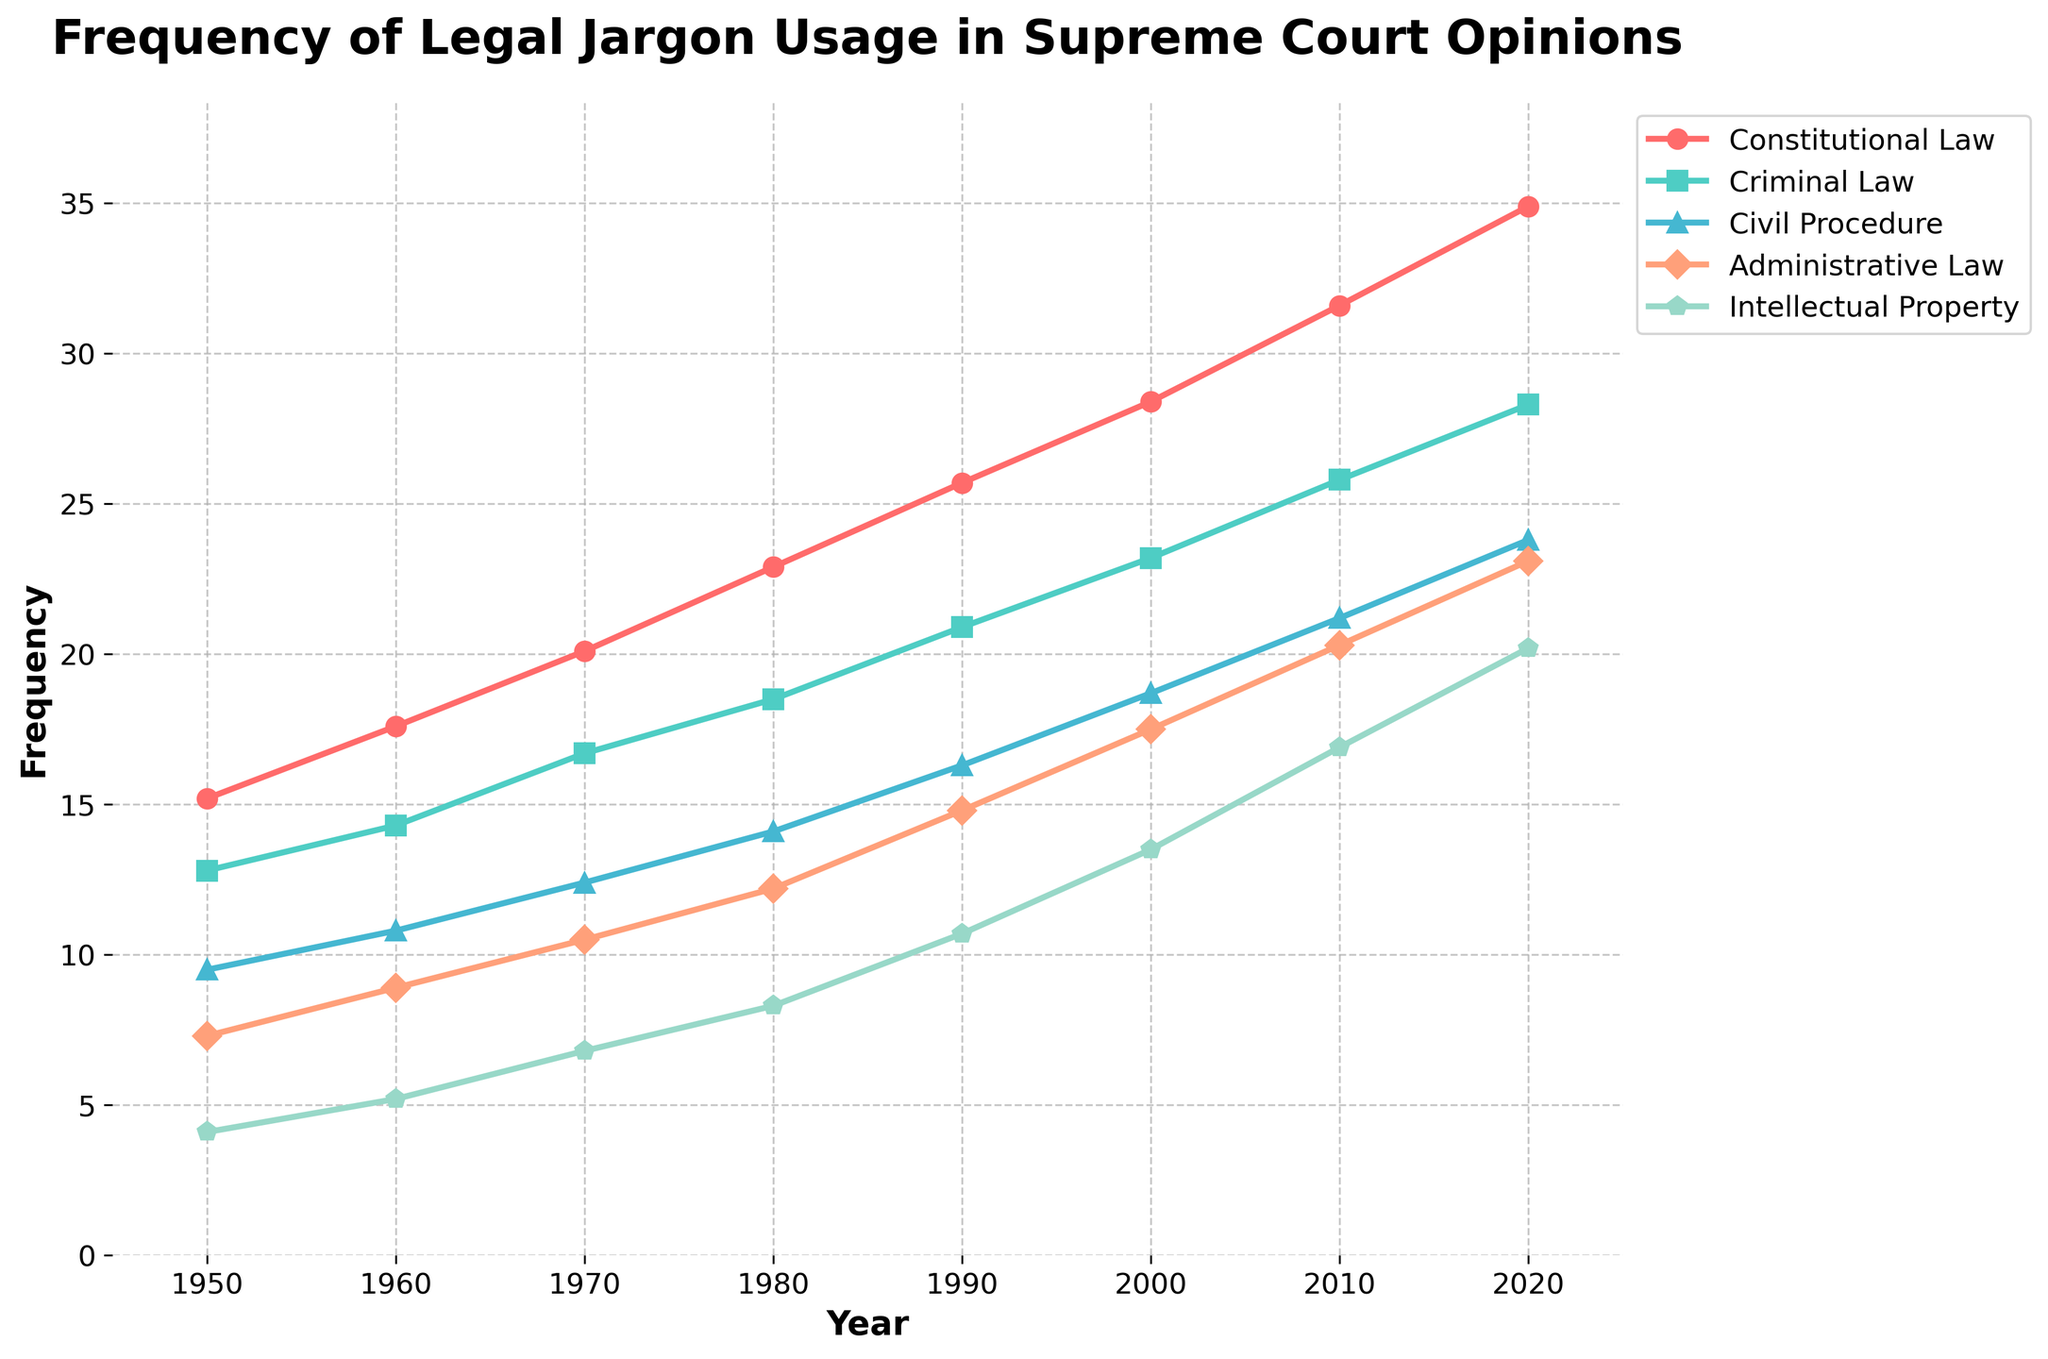what area of law had the highest frequency in 2020? Look at the 2020 value for each line and identify the highest. "Constitutional Law" is the highest at 34.9.
Answer: Constitutional Law Which two areas of law had the closest frequencies in 1970? Compare the values for each area in 1970 to find the two closest: Criminal Law (16.7) and Civil Procedure (12.4) differ by 4.3.
Answer: Criminal Law and Civil Procedure Which area of law saw the largest change in frequency from 1950 to 2020? Calculate the change for each area from 1950 to 2020. Constitutional Law changed by 34.9 - 15.2 = 19.7, which is the largest increase.
Answer: Constitutional Law What is the average frequency of Intellectual Property over the years provided? Sum the frequencies for Intellectual Property and divide by the number of years: (4.1 + 5.2 + 6.8 + 8.3 + 10.7 + 13.5 + 16.9 + 20.2) / 8 = 10.7
Answer: 10.7 Which area of law had the lowest frequency in 1980? Look at the 1980 values for each area and identify the lowest: "Intellectual Property" at 8.3.
Answer: Intellectual Property In what year did Civil Procedure surpass 20 in frequency? Identify the year where Civil Procedure first exceeds 20: It was 2010 with a value of 21.2.
Answer: 2010 How much did Administrative Law grow from 1990 to 2010? Subtract the 1990 value from the 2010 value for Administrative Law: 20.3 - 14.8 = 5.5
Answer: 5.5 What is the difference in frequency between Criminal Law and Intellectual Property in 2020? Subtract the 2020 value of Intellectual Property from Criminal Law: 28.3 - 20.2 = 8.1
Answer: 8.1 Which color represents the trend of Criminal Law in the visual? Identify the color used for the Criminal Law line in the plot, which is turquoise.
Answer: turquoise Which area saw its frequency more than triple from 1950 to 2020? Identify the areas whose 2020 value is more than three times their 1950 value. Intellectual Property went from 4.1 to 20.2, which is more than triple.
Answer: Intellectual Property 